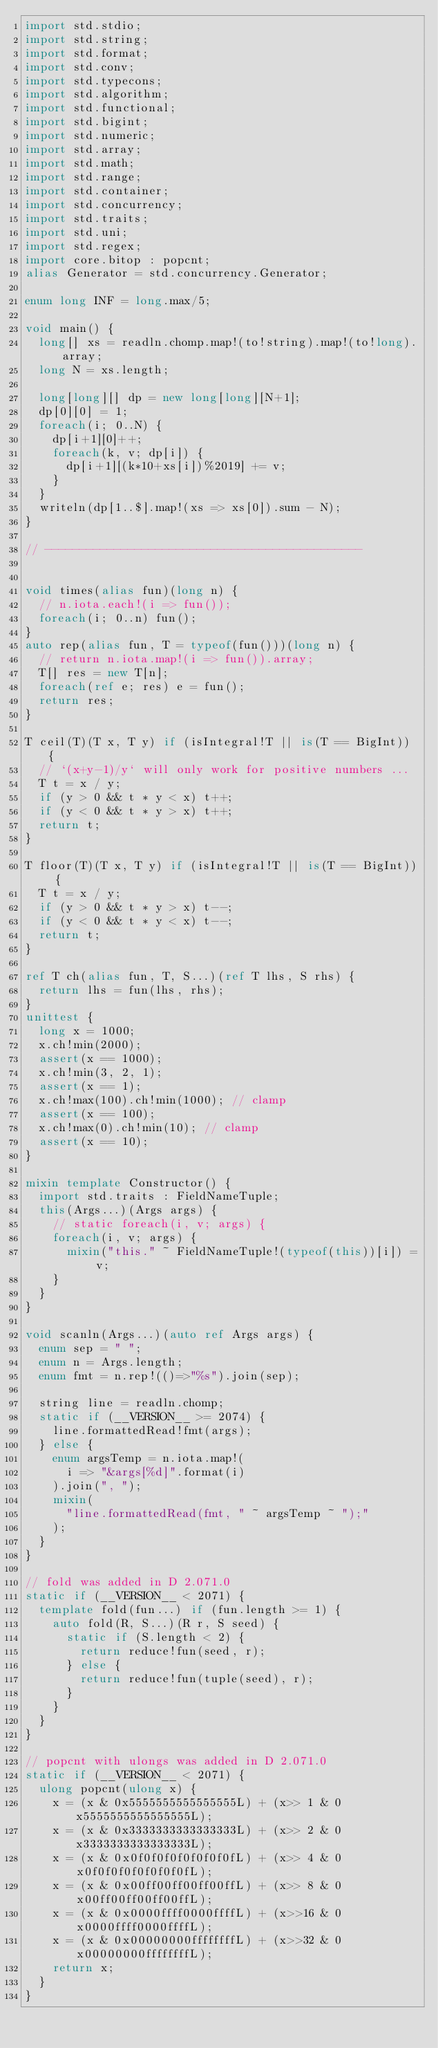Convert code to text. <code><loc_0><loc_0><loc_500><loc_500><_D_>import std.stdio;
import std.string;
import std.format;
import std.conv;
import std.typecons;
import std.algorithm;
import std.functional;
import std.bigint;
import std.numeric;
import std.array;
import std.math;
import std.range;
import std.container;
import std.concurrency;
import std.traits;
import std.uni;
import std.regex;
import core.bitop : popcnt;
alias Generator = std.concurrency.Generator;

enum long INF = long.max/5;

void main() {
  long[] xs = readln.chomp.map!(to!string).map!(to!long).array;
  long N = xs.length;

  long[long][] dp = new long[long][N+1];
  dp[0][0] = 1;
  foreach(i; 0..N) {
    dp[i+1][0]++;
    foreach(k, v; dp[i]) {
      dp[i+1][(k*10+xs[i])%2019] += v;
    }
  }
  writeln(dp[1..$].map!(xs => xs[0]).sum - N);
}

// ----------------------------------------------


void times(alias fun)(long n) {
  // n.iota.each!(i => fun());
  foreach(i; 0..n) fun();
}
auto rep(alias fun, T = typeof(fun()))(long n) {
  // return n.iota.map!(i => fun()).array;
  T[] res = new T[n];
  foreach(ref e; res) e = fun();
  return res;
}

T ceil(T)(T x, T y) if (isIntegral!T || is(T == BigInt)) {
  // `(x+y-1)/y` will only work for positive numbers ...
  T t = x / y;
  if (y > 0 && t * y < x) t++;
  if (y < 0 && t * y > x) t++;
  return t;
}

T floor(T)(T x, T y) if (isIntegral!T || is(T == BigInt)) {
  T t = x / y;
  if (y > 0 && t * y > x) t--;
  if (y < 0 && t * y < x) t--;
  return t;
}

ref T ch(alias fun, T, S...)(ref T lhs, S rhs) {
  return lhs = fun(lhs, rhs);
}
unittest {
  long x = 1000;
  x.ch!min(2000);
  assert(x == 1000);
  x.ch!min(3, 2, 1);
  assert(x == 1);
  x.ch!max(100).ch!min(1000); // clamp
  assert(x == 100);
  x.ch!max(0).ch!min(10); // clamp
  assert(x == 10);
}

mixin template Constructor() {
  import std.traits : FieldNameTuple;
  this(Args...)(Args args) {
    // static foreach(i, v; args) {
    foreach(i, v; args) {
      mixin("this." ~ FieldNameTuple!(typeof(this))[i]) = v;
    }
  }
}

void scanln(Args...)(auto ref Args args) {
  enum sep = " ";
  enum n = Args.length;
  enum fmt = n.rep!(()=>"%s").join(sep);

  string line = readln.chomp;
  static if (__VERSION__ >= 2074) {
    line.formattedRead!fmt(args);
  } else {
    enum argsTemp = n.iota.map!(
      i => "&args[%d]".format(i)
    ).join(", ");
    mixin(
      "line.formattedRead(fmt, " ~ argsTemp ~ ");"
    );
  }
}

// fold was added in D 2.071.0
static if (__VERSION__ < 2071) {
  template fold(fun...) if (fun.length >= 1) {
    auto fold(R, S...)(R r, S seed) {
      static if (S.length < 2) {
        return reduce!fun(seed, r);
      } else {
        return reduce!fun(tuple(seed), r);
      }
    }
  }
}

// popcnt with ulongs was added in D 2.071.0
static if (__VERSION__ < 2071) {
  ulong popcnt(ulong x) {
    x = (x & 0x5555555555555555L) + (x>> 1 & 0x5555555555555555L);
    x = (x & 0x3333333333333333L) + (x>> 2 & 0x3333333333333333L);
    x = (x & 0x0f0f0f0f0f0f0f0fL) + (x>> 4 & 0x0f0f0f0f0f0f0f0fL);
    x = (x & 0x00ff00ff00ff00ffL) + (x>> 8 & 0x00ff00ff00ff00ffL);
    x = (x & 0x0000ffff0000ffffL) + (x>>16 & 0x0000ffff0000ffffL);
    x = (x & 0x00000000ffffffffL) + (x>>32 & 0x00000000ffffffffL);
    return x;
  }
}
</code> 